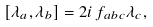Convert formula to latex. <formula><loc_0><loc_0><loc_500><loc_500>\left [ \lambda _ { a } , \lambda _ { b } \right ] = 2 i \, f _ { a b c } \lambda _ { c } ,</formula> 